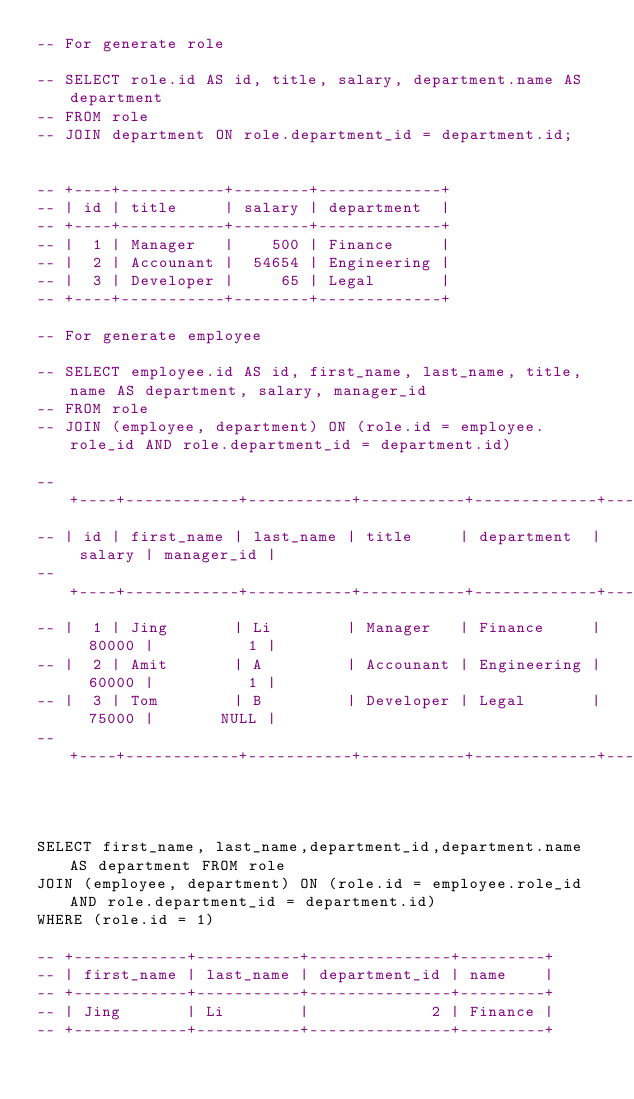Convert code to text. <code><loc_0><loc_0><loc_500><loc_500><_SQL_>-- For generate role

-- SELECT role.id AS id, title, salary, department.name AS department
-- FROM role
-- JOIN department ON role.department_id = department.id;


-- +----+-----------+--------+-------------+
-- | id | title     | salary | department  |
-- +----+-----------+--------+-------------+
-- |  1 | Manager   |    500 | Finance     |
-- |  2 | Accounant |  54654 | Engineering |
-- |  3 | Developer |     65 | Legal       |
-- +----+-----------+--------+-------------+

-- For generate employee

-- SELECT employee.id AS id, first_name, last_name, title, name AS department, salary, manager_id 
-- FROM role
-- JOIN (employee, department) ON (role.id = employee.role_id AND role.department_id = department.id)

-- +----+------------+-----------+-----------+-------------+--------+------------+
-- | id | first_name | last_name | title     | department  | salary | manager_id |
-- +----+------------+-----------+-----------+-------------+--------+------------+
-- |  1 | Jing       | Li        | Manager   | Finance     |  80000 |          1 |
-- |  2 | Amit       | A         | Accounant | Engineering |  60000 |          1 |
-- |  3 | Tom        | B         | Developer | Legal       |  75000 |       NULL |
-- +----+------------+-----------+-----------+-------------+--------+------------+



SELECT first_name, last_name,department_id,department.name AS department FROM role
JOIN (employee, department) ON (role.id = employee.role_id AND role.department_id = department.id)
WHERE (role.id = 1)

-- +------------+-----------+---------------+---------+
-- | first_name | last_name | department_id | name    |
-- +------------+-----------+---------------+---------+
-- | Jing       | Li        |             2 | Finance |
-- +------------+-----------+---------------+---------+

</code> 